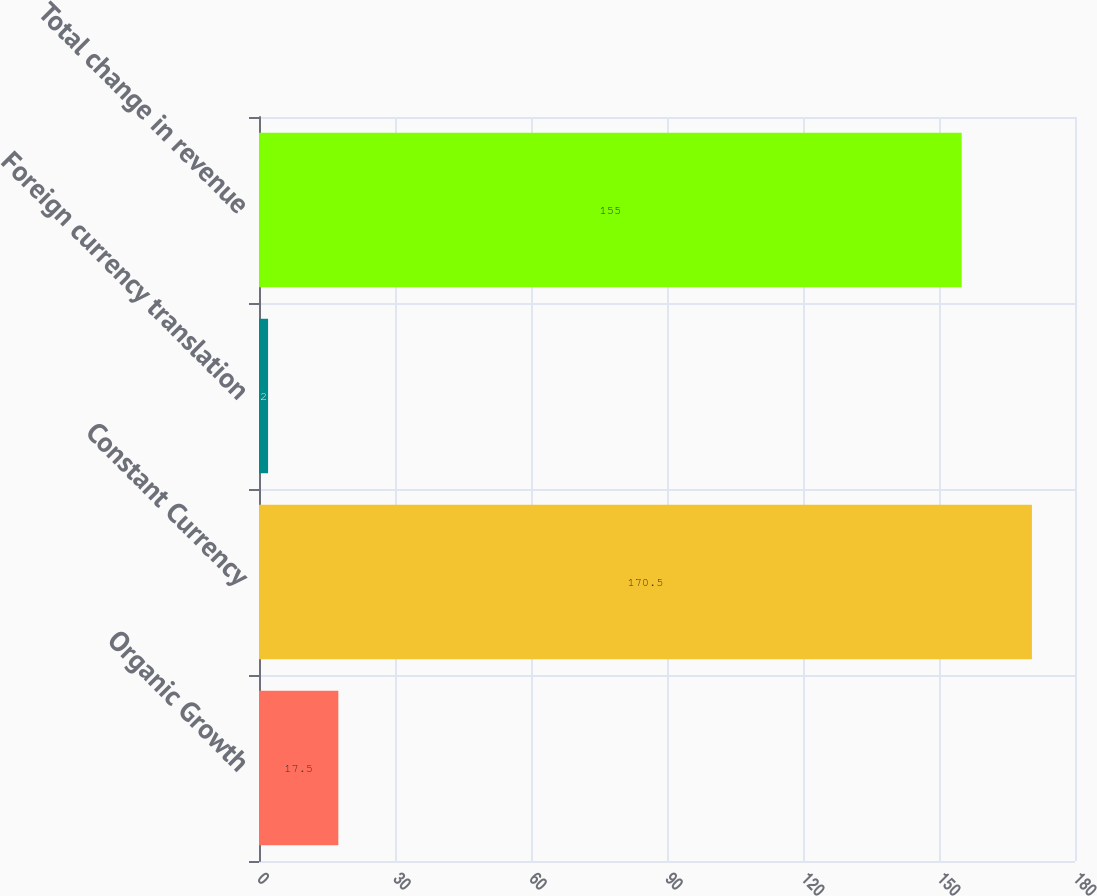Convert chart. <chart><loc_0><loc_0><loc_500><loc_500><bar_chart><fcel>Organic Growth<fcel>Constant Currency<fcel>Foreign currency translation<fcel>Total change in revenue<nl><fcel>17.5<fcel>170.5<fcel>2<fcel>155<nl></chart> 